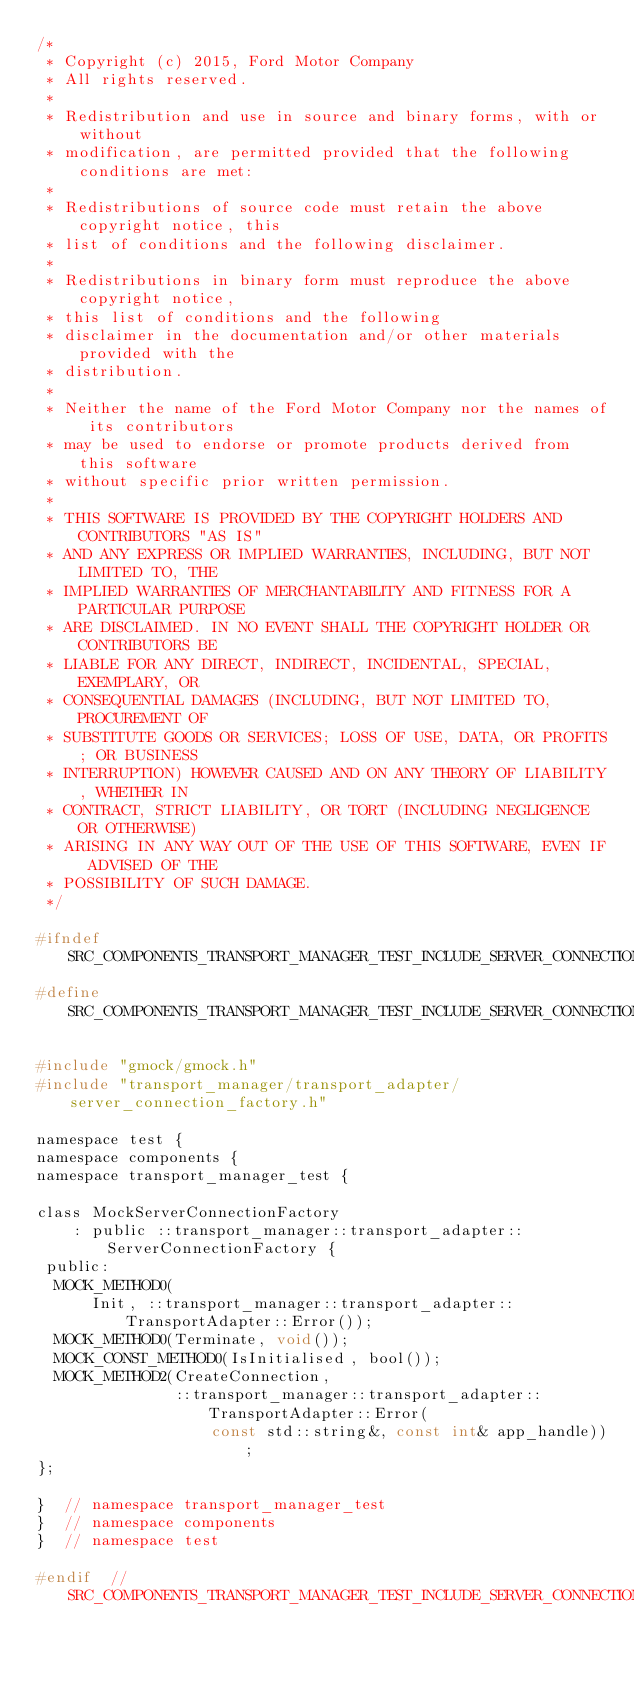<code> <loc_0><loc_0><loc_500><loc_500><_C_>/*
 * Copyright (c) 2015, Ford Motor Company
 * All rights reserved.
 *
 * Redistribution and use in source and binary forms, with or without
 * modification, are permitted provided that the following conditions are met:
 *
 * Redistributions of source code must retain the above copyright notice, this
 * list of conditions and the following disclaimer.
 *
 * Redistributions in binary form must reproduce the above copyright notice,
 * this list of conditions and the following
 * disclaimer in the documentation and/or other materials provided with the
 * distribution.
 *
 * Neither the name of the Ford Motor Company nor the names of its contributors
 * may be used to endorse or promote products derived from this software
 * without specific prior written permission.
 *
 * THIS SOFTWARE IS PROVIDED BY THE COPYRIGHT HOLDERS AND CONTRIBUTORS "AS IS"
 * AND ANY EXPRESS OR IMPLIED WARRANTIES, INCLUDING, BUT NOT LIMITED TO, THE
 * IMPLIED WARRANTIES OF MERCHANTABILITY AND FITNESS FOR A PARTICULAR PURPOSE
 * ARE DISCLAIMED. IN NO EVENT SHALL THE COPYRIGHT HOLDER OR CONTRIBUTORS BE
 * LIABLE FOR ANY DIRECT, INDIRECT, INCIDENTAL, SPECIAL, EXEMPLARY, OR
 * CONSEQUENTIAL DAMAGES (INCLUDING, BUT NOT LIMITED TO, PROCUREMENT OF
 * SUBSTITUTE GOODS OR SERVICES; LOSS OF USE, DATA, OR PROFITS; OR BUSINESS
 * INTERRUPTION) HOWEVER CAUSED AND ON ANY THEORY OF LIABILITY, WHETHER IN
 * CONTRACT, STRICT LIABILITY, OR TORT (INCLUDING NEGLIGENCE OR OTHERWISE)
 * ARISING IN ANY WAY OUT OF THE USE OF THIS SOFTWARE, EVEN IF ADVISED OF THE
 * POSSIBILITY OF SUCH DAMAGE.
 */

#ifndef SRC_COMPONENTS_TRANSPORT_MANAGER_TEST_INCLUDE_SERVER_CONNECTION_FACTORY_MOCK_H_
#define SRC_COMPONENTS_TRANSPORT_MANAGER_TEST_INCLUDE_SERVER_CONNECTION_FACTORY_MOCK_H_

#include "gmock/gmock.h"
#include "transport_manager/transport_adapter/server_connection_factory.h"

namespace test {
namespace components {
namespace transport_manager_test {

class MockServerConnectionFactory
    : public ::transport_manager::transport_adapter::ServerConnectionFactory {
 public:
  MOCK_METHOD0(
      Init, ::transport_manager::transport_adapter::TransportAdapter::Error());
  MOCK_METHOD0(Terminate, void());
  MOCK_CONST_METHOD0(IsInitialised, bool());
  MOCK_METHOD2(CreateConnection,
               ::transport_manager::transport_adapter::TransportAdapter::Error(
                   const std::string&, const int& app_handle));
};

}  // namespace transport_manager_test
}  // namespace components
}  // namespace test

#endif  // SRC_COMPONENTS_TRANSPORT_MANAGER_TEST_INCLUDE_SERVER_CONNECTION_FACTORY_MOCK_H_
</code> 